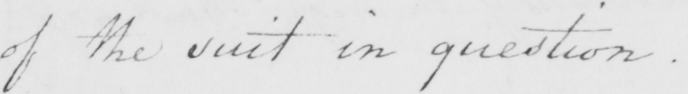Please provide the text content of this handwritten line. of the suit in question . 